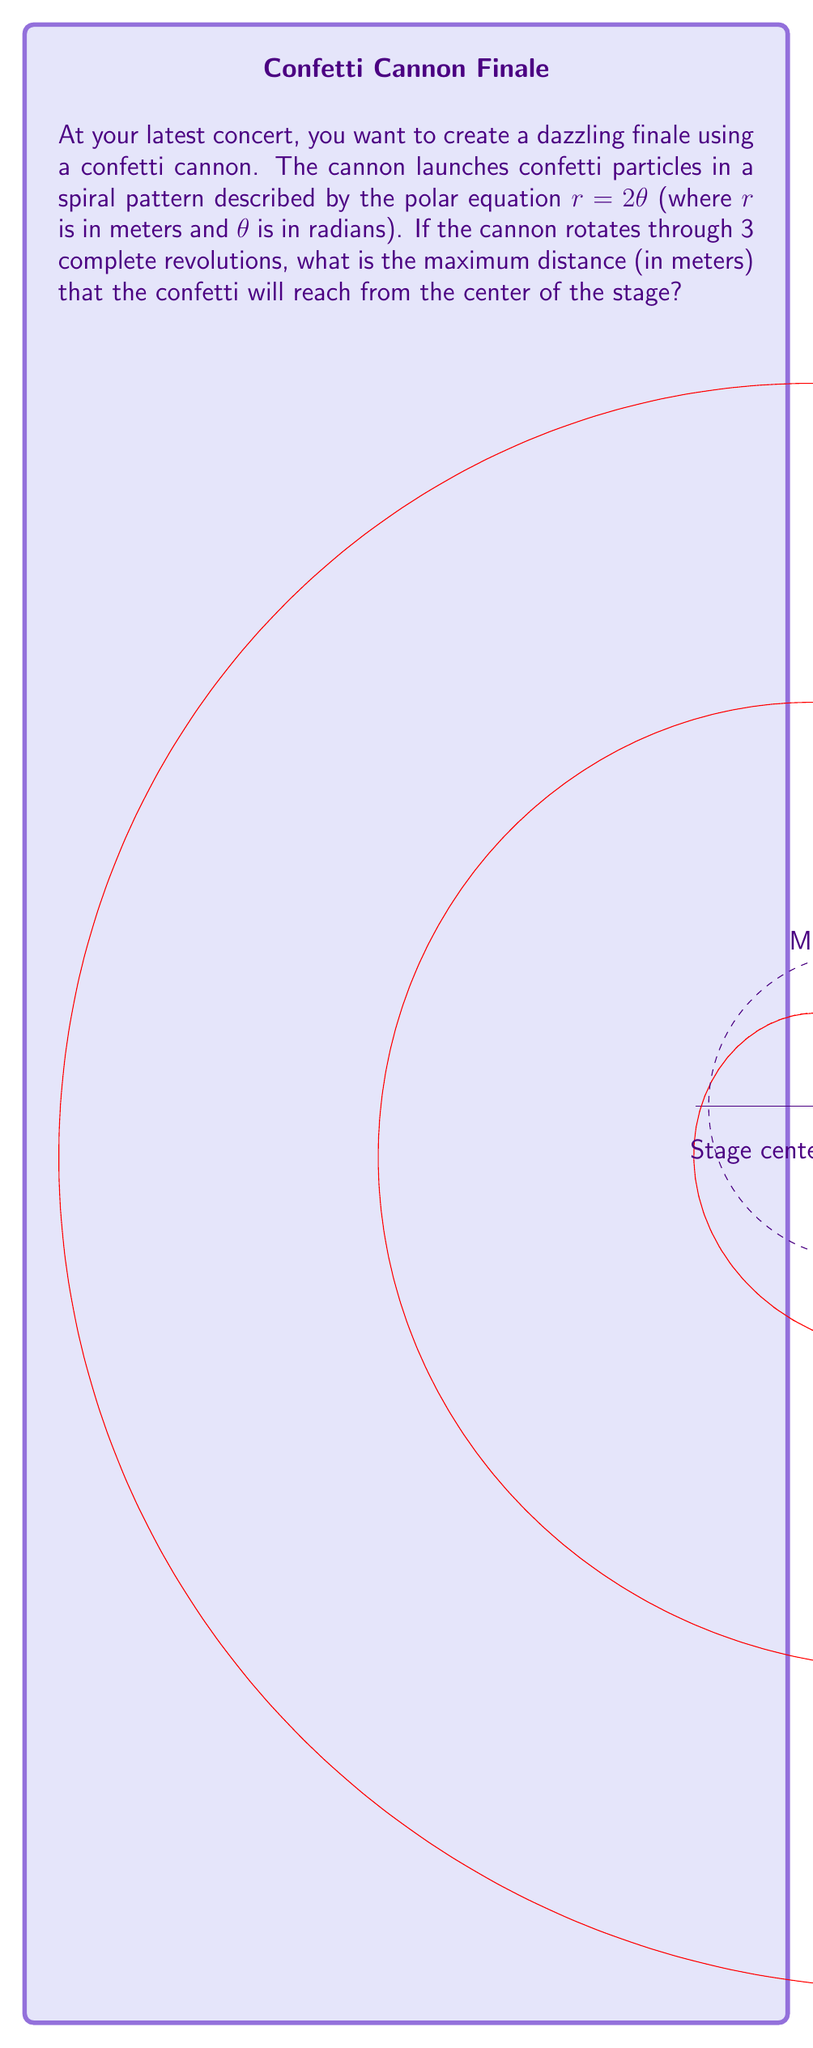Solve this math problem. Let's approach this step-by-step:

1) The polar equation of the confetti trajectory is given as $r = 2\theta$, where $r$ is the distance from the center and $\theta$ is the angle in radians.

2) We need to find the maximum value of $r$ over 3 complete revolutions.

3) One complete revolution is $2\pi$ radians. So, 3 revolutions would be:
   $$\theta_{max} = 3 \cdot 2\pi = 6\pi \text{ radians}$$

4) To find the maximum distance, we substitute this maximum $\theta$ into our equation:
   $$r_{max} = 2\theta_{max} = 2(6\pi) = 12\pi$$

5) Therefore, the maximum distance the confetti will reach is $12\pi$ meters from the center of the stage.
Answer: $12\pi$ meters 